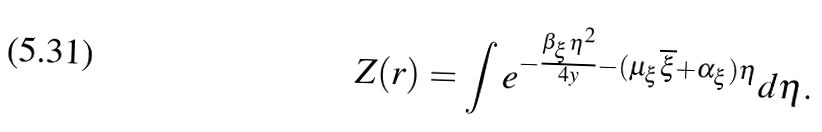<formula> <loc_0><loc_0><loc_500><loc_500>Z ( { r } ) = \int e ^ { - \frac { \beta _ { \xi } \eta ^ { 2 } } { 4 y } - ( \mu _ { \xi } \overline { \xi } + \alpha _ { \xi } ) \eta } d \eta .</formula> 